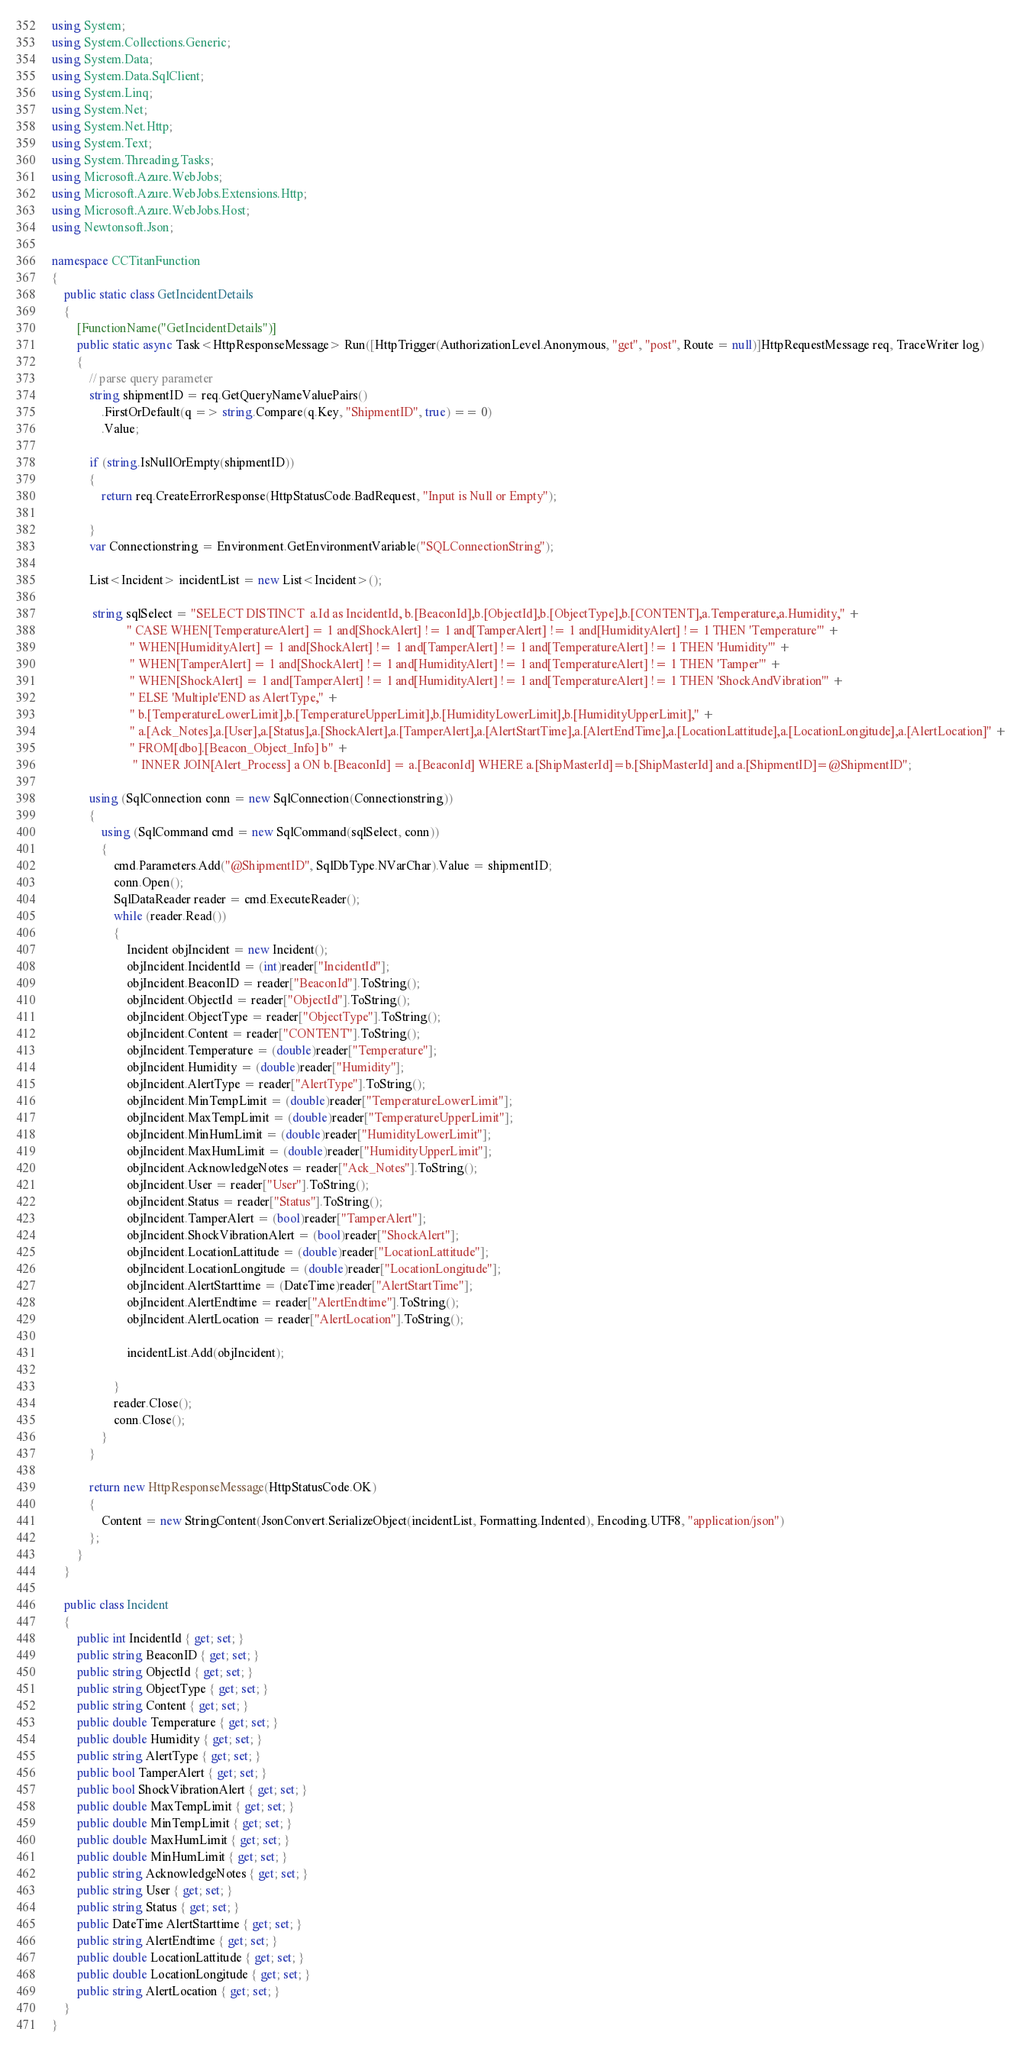<code> <loc_0><loc_0><loc_500><loc_500><_C#_>using System;
using System.Collections.Generic;
using System.Data;
using System.Data.SqlClient;
using System.Linq;
using System.Net;
using System.Net.Http;
using System.Text;
using System.Threading.Tasks;
using Microsoft.Azure.WebJobs;
using Microsoft.Azure.WebJobs.Extensions.Http;
using Microsoft.Azure.WebJobs.Host;
using Newtonsoft.Json;

namespace CCTitanFunction
{
    public static class GetIncidentDetails
    {
        [FunctionName("GetIncidentDetails")]
        public static async Task<HttpResponseMessage> Run([HttpTrigger(AuthorizationLevel.Anonymous, "get", "post", Route = null)]HttpRequestMessage req, TraceWriter log)
        {
            // parse query parameter
            string shipmentID = req.GetQueryNameValuePairs()
                .FirstOrDefault(q => string.Compare(q.Key, "ShipmentID", true) == 0)
                .Value;      

            if (string.IsNullOrEmpty(shipmentID))
            {
                return req.CreateErrorResponse(HttpStatusCode.BadRequest, "Input is Null or Empty");

            }
            var Connectionstring = Environment.GetEnvironmentVariable("SQLConnectionString");

            List<Incident> incidentList = new List<Incident>();

             string sqlSelect = "SELECT DISTINCT  a.Id as IncidentId, b.[BeaconId],b.[ObjectId],b.[ObjectType],b.[CONTENT],a.Temperature,a.Humidity," +
                        " CASE WHEN[TemperatureAlert] = 1 and[ShockAlert] != 1 and[TamperAlert] != 1 and[HumidityAlert] != 1 THEN 'Temperature'" +
                         " WHEN[HumidityAlert] = 1 and[ShockAlert] != 1 and[TamperAlert] != 1 and[TemperatureAlert] != 1 THEN 'Humidity'" +
                         " WHEN[TamperAlert] = 1 and[ShockAlert] != 1 and[HumidityAlert] != 1 and[TemperatureAlert] != 1 THEN 'Tamper'" +
                         " WHEN[ShockAlert] = 1 and[TamperAlert] != 1 and[HumidityAlert] != 1 and[TemperatureAlert] != 1 THEN 'ShockAndVibration'" +
                         " ELSE 'Multiple'END as AlertType," +
                         " b.[TemperatureLowerLimit],b.[TemperatureUpperLimit],b.[HumidityLowerLimit],b.[HumidityUpperLimit]," +
                         " a.[Ack_Notes],a.[User],a.[Status],a.[ShockAlert],a.[TamperAlert],a.[AlertStartTime],a.[AlertEndTime],a.[LocationLattitude],a.[LocationLongitude],a.[AlertLocation]" +
                         " FROM[dbo].[Beacon_Object_Info] b" +
                          " INNER JOIN[Alert_Process] a ON b.[BeaconId] = a.[BeaconId] WHERE a.[ShipMasterId]=b.[ShipMasterId] and a.[ShipmentID]=@ShipmentID";

            using (SqlConnection conn = new SqlConnection(Connectionstring))
            {
                using (SqlCommand cmd = new SqlCommand(sqlSelect, conn))
                {
                    cmd.Parameters.Add("@ShipmentID", SqlDbType.NVarChar).Value = shipmentID;                    
                    conn.Open();
                    SqlDataReader reader = cmd.ExecuteReader();
                    while (reader.Read())
                    {
                        Incident objIncident = new Incident();
                        objIncident.IncidentId = (int)reader["IncidentId"];
                        objIncident.BeaconID = reader["BeaconId"].ToString();
                        objIncident.ObjectId = reader["ObjectId"].ToString();
                        objIncident.ObjectType = reader["ObjectType"].ToString();
                        objIncident.Content = reader["CONTENT"].ToString();
                        objIncident.Temperature = (double)reader["Temperature"];
                        objIncident.Humidity = (double)reader["Humidity"];
                        objIncident.AlertType = reader["AlertType"].ToString();
                        objIncident.MinTempLimit = (double)reader["TemperatureLowerLimit"];
                        objIncident.MaxTempLimit = (double)reader["TemperatureUpperLimit"];
                        objIncident.MinHumLimit = (double)reader["HumidityLowerLimit"];
                        objIncident.MaxHumLimit = (double)reader["HumidityUpperLimit"];
                        objIncident.AcknowledgeNotes = reader["Ack_Notes"].ToString();
                        objIncident.User = reader["User"].ToString();
                        objIncident.Status = reader["Status"].ToString();
                        objIncident.TamperAlert = (bool)reader["TamperAlert"];
                        objIncident.ShockVibrationAlert = (bool)reader["ShockAlert"];
                        objIncident.LocationLattitude = (double)reader["LocationLattitude"];
                        objIncident.LocationLongitude = (double)reader["LocationLongitude"];
                        objIncident.AlertStarttime = (DateTime)reader["AlertStartTime"];
                        objIncident.AlertEndtime = reader["AlertEndtime"].ToString();
                        objIncident.AlertLocation = reader["AlertLocation"].ToString();
                        
                        incidentList.Add(objIncident);

                    }
                    reader.Close();
                    conn.Close();
                }
            }

            return new HttpResponseMessage(HttpStatusCode.OK)
            {
                Content = new StringContent(JsonConvert.SerializeObject(incidentList, Formatting.Indented), Encoding.UTF8, "application/json")
            };
        }
    }

    public class Incident
    {
        public int IncidentId { get; set; }
        public string BeaconID { get; set; }
        public string ObjectId { get; set; }
        public string ObjectType { get; set; }
        public string Content { get; set; }
        public double Temperature { get; set; }
        public double Humidity { get; set; }
        public string AlertType { get; set; }
        public bool TamperAlert { get; set; }
        public bool ShockVibrationAlert { get; set; }
        public double MaxTempLimit { get; set; }
        public double MinTempLimit { get; set; }
        public double MaxHumLimit { get; set; }
        public double MinHumLimit { get; set; }
        public string AcknowledgeNotes { get; set; }
        public string User { get; set; }
        public string Status { get; set; }
        public DateTime AlertStarttime { get; set; }
        public string AlertEndtime { get; set; }
        public double LocationLattitude { get; set; }
        public double LocationLongitude { get; set; }
        public string AlertLocation { get; set; }
    }
}
</code> 